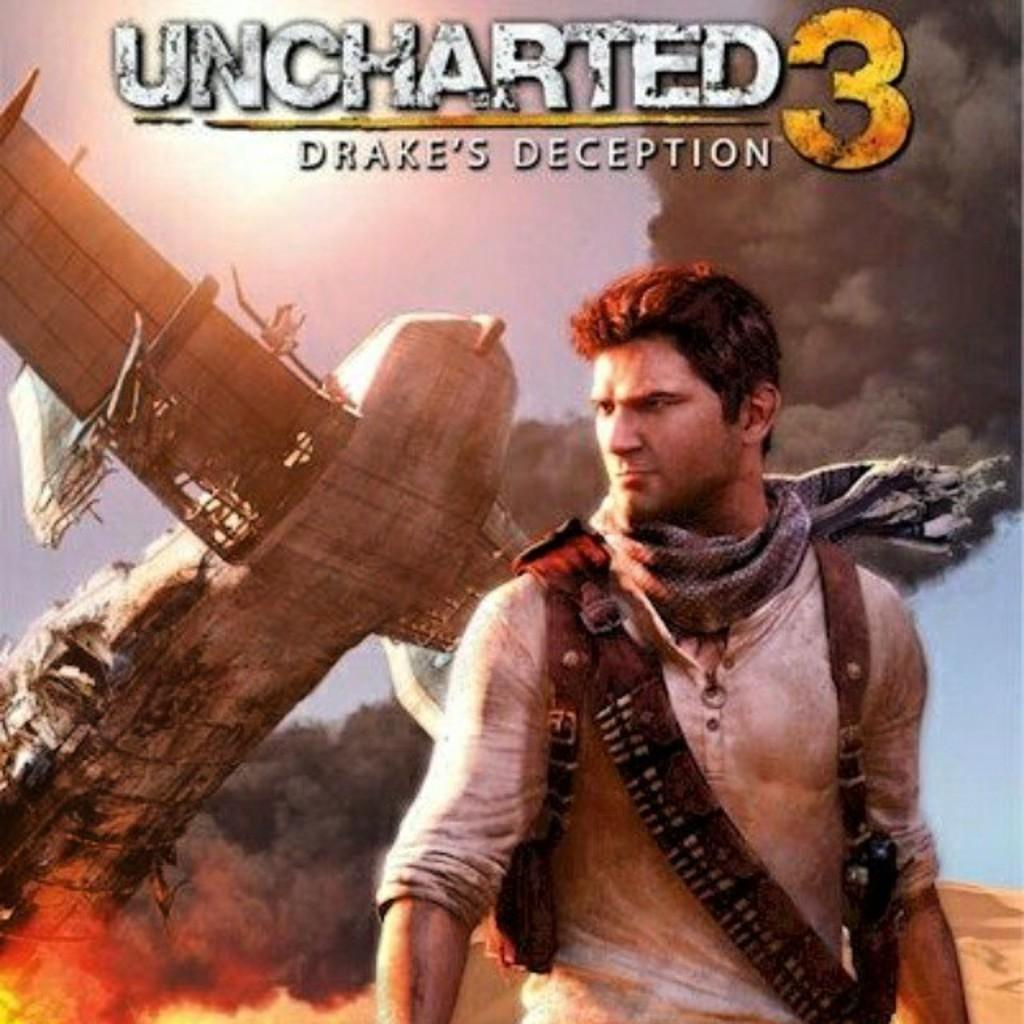<image>
Render a clear and concise summary of the photo. the plane and man are on the cover of Unchartered 3 